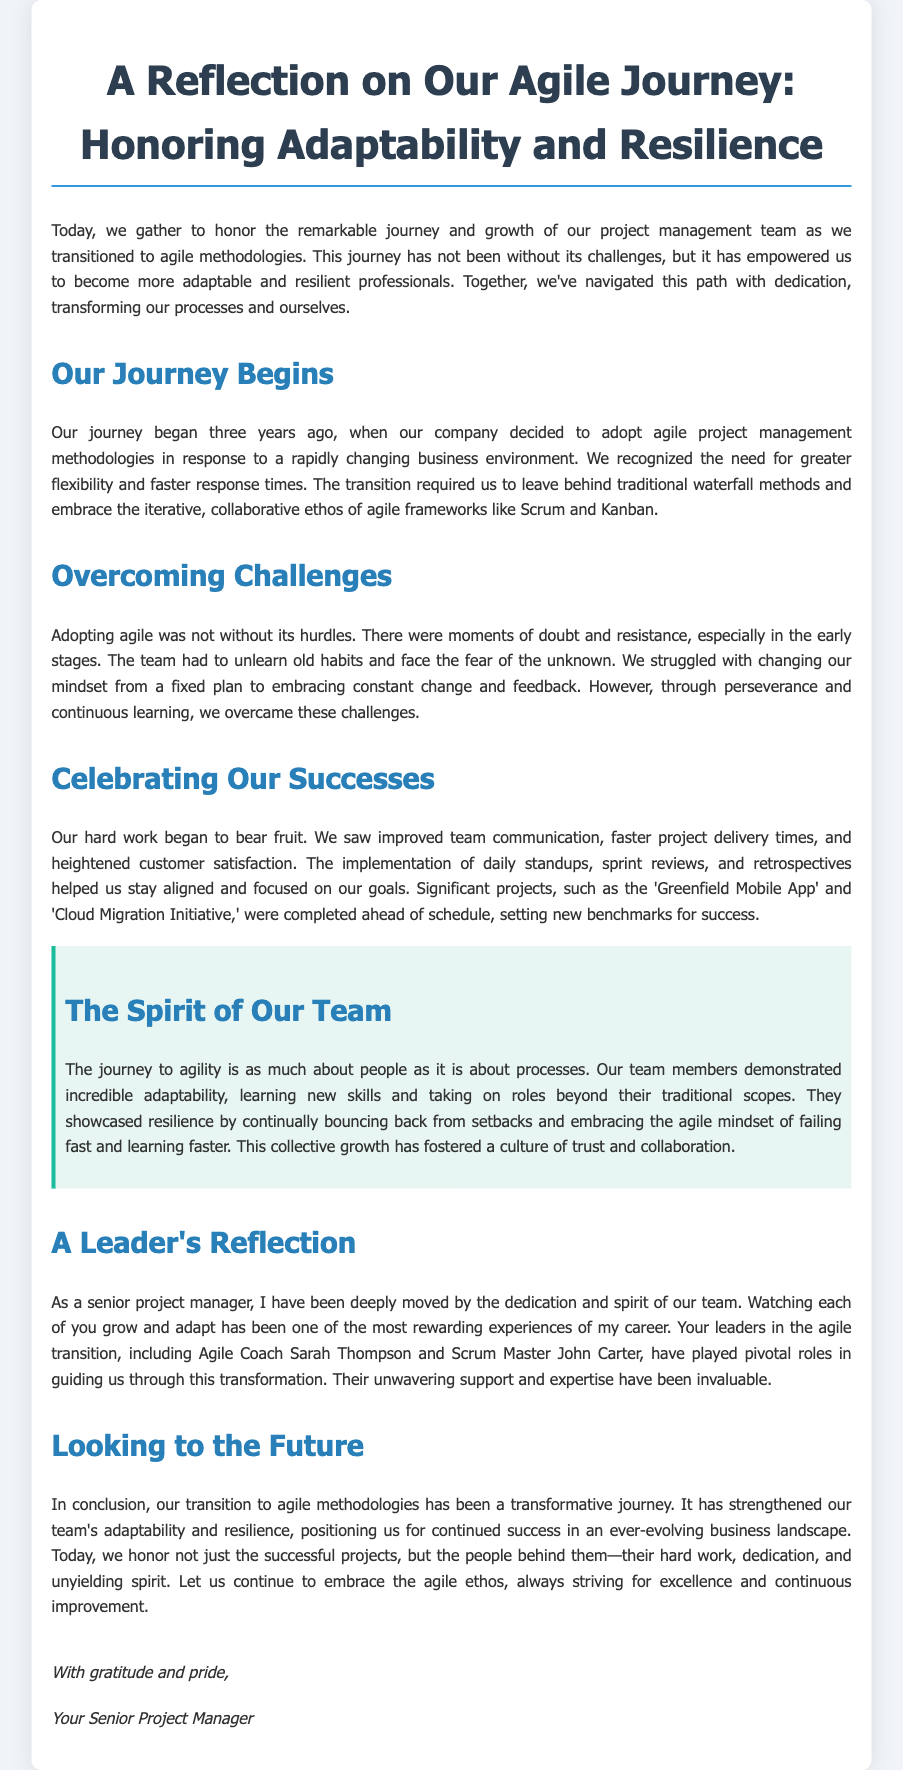What is the title of the document? The title of the document is present in the header section, which reflects the main theme of the eulogy.
Answer: A Reflection on Our Agile Journey: Honoring Adaptability and Resilience How long ago did the journey begin? The document states that the journey began three years ago when the company decided to adopt agile methodologies.
Answer: Three years ago What methodologies did the team transition from? The document mentions leaving behind traditional methods, specifically indicating the shift from a certain approach to agile methodologies.
Answer: Waterfall methods What were two significant projects completed ahead of schedule? The document lists examples of projects that set new benchmarks for success during the agile transition.
Answer: Greenfield Mobile App and Cloud Migration Initiative Who played pivotal roles in guiding the team? The document highlights key individuals who provided support during the agile transition.
Answer: Agile Coach Sarah Thompson and Scrum Master John Carter What did the implementation of daily standups improve? The document notes specific improvements resulting from new practices adopted during the agile transition.
Answer: Team communication What mindset did the team have to change? The document discusses the initial challenges of shifting perspective concerning project planning and adjustments.
Answer: Fixed plan to embracing constant change What does the document emphasize about the journey to agility? The eulogy reflects on aspects that are as significant as the methods used, focusing on personal growth during the project management journey.
Answer: People and processes 